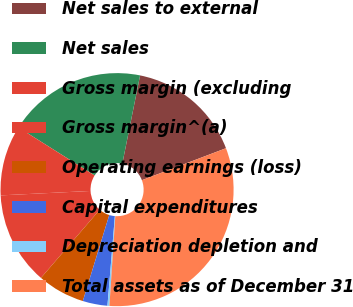Convert chart to OTSL. <chart><loc_0><loc_0><loc_500><loc_500><pie_chart><fcel>Net sales to external<fcel>Net sales<fcel>Gross margin (excluding<fcel>Gross margin^(a)<fcel>Operating earnings (loss)<fcel>Capital expenditures<fcel>Depreciation depletion and<fcel>Total assets as of December 31<nl><fcel>16.05%<fcel>19.21%<fcel>9.74%<fcel>12.89%<fcel>6.58%<fcel>3.43%<fcel>0.27%<fcel>31.83%<nl></chart> 